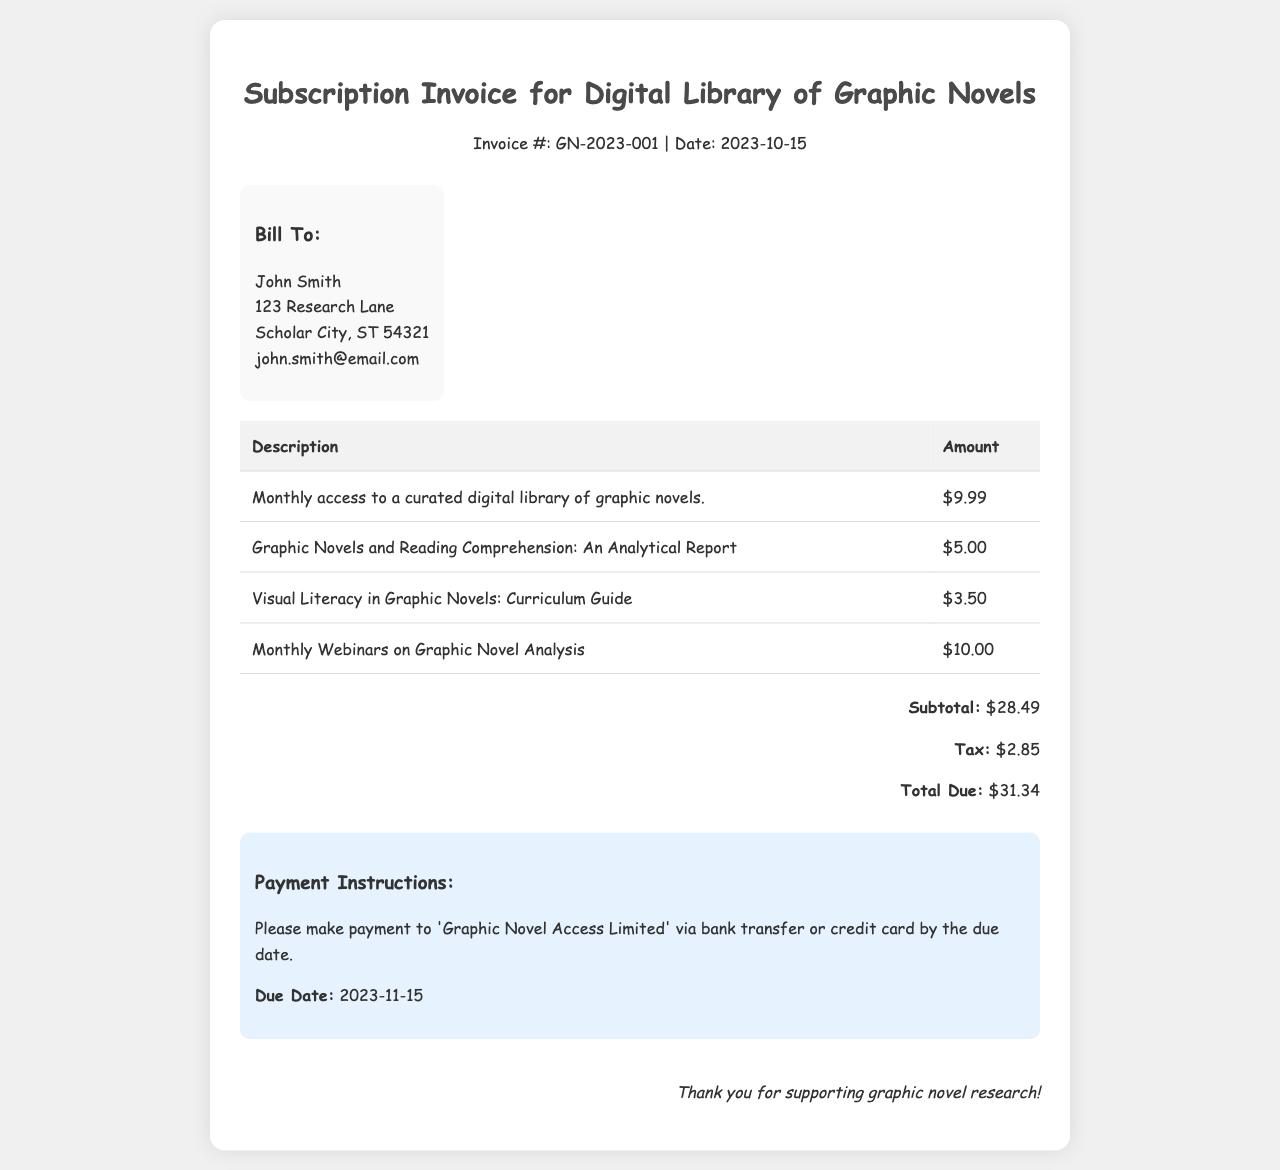What is the invoice number? The invoice number is specified in the document as GN-2023-001.
Answer: GN-2023-001 What is the due date for payment? The due date for payment is indicated in the payment instructions section, which states 2023-11-15.
Answer: 2023-11-15 How much is the monthly membership fee? The monthly membership fee is listed in the invoice as $9.99.
Answer: $9.99 What resources are included in the invoice? The invoice lists multiple resources, including reports and webinars, specifically "Graphic Novels and Reading Comprehension: An Analytical Report," "Visual Literacy in Graphic Novels: Curriculum Guide," and "Monthly Webinars on Graphic Novel Analysis."
Answer: Reports and webinars What is the subtotal amount? The subtotal is presented toward the end of the invoice, amounting to $28.49.
Answer: $28.49 How much tax is applied? The tax amount is provided in the totals section, which shows it as $2.85.
Answer: $2.85 What is the total due? The total due is specified in the totals section of the invoice as $31.34.
Answer: $31.34 What is the payment method mentioned? The document states that payment can be made via bank transfer or credit card.
Answer: Bank transfer or credit card Who is the invoice addressed to? The bill-to section identifies the recipient's name as John Smith.
Answer: John Smith 